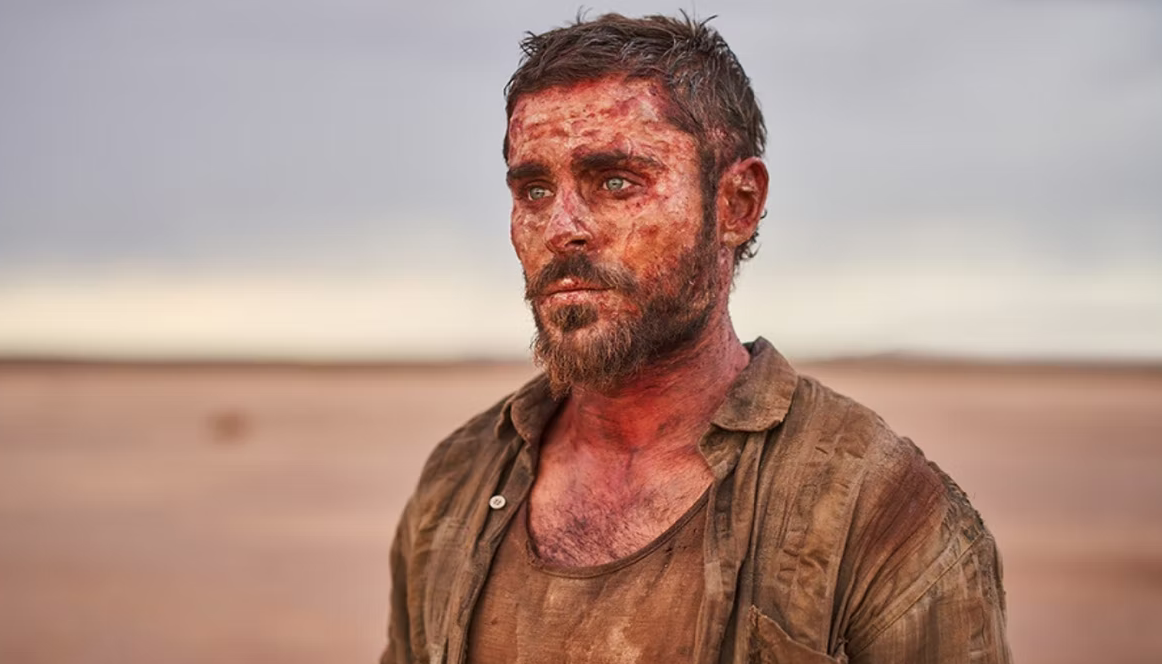Describe a plausible short scenario explaining his situation. He might have been a traveler whose vehicle broke down in the middle of the desert. With no immediate help available, he decided to walk in search of assistance. The journey turned out to be far longer and more dangerous than anticipated, leading to his current state of exhaustion and disarray. 